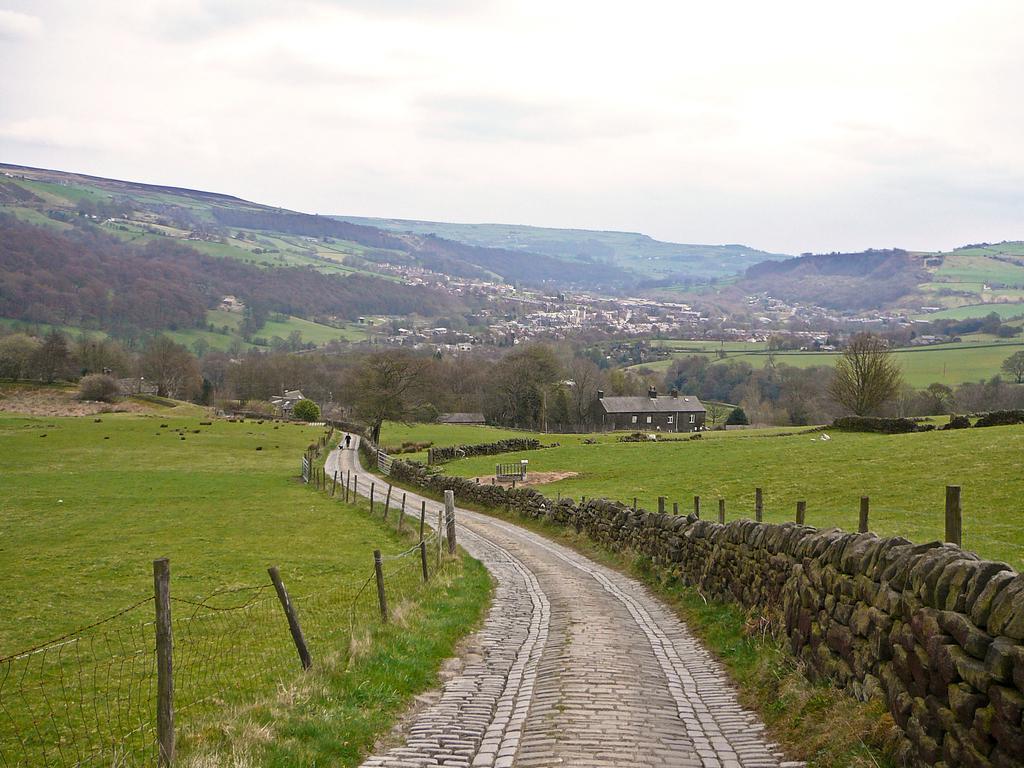Describe this image in one or two sentences. In this image, we can see fences, sheds, trees, poles, buildings and hills. At the top, there is sky and at the bottom, there is ground. 